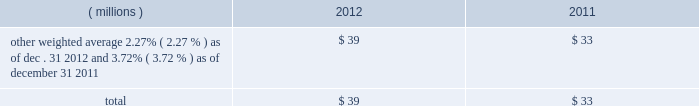2012 ppg annual report and form 10-k 45 costs related to these notes , which totaled $ 17 million , will be amortized to interest expense over the respective terms of the notes .
In august 2010 , ppg entered into a three-year credit agreement with several banks and financial institutions ( the "2010 credit agreement" ) which was subsequently terminated in july 2012 .
The 2010 credit agreement provided for a $ 1.2 billion unsecured revolving credit facility .
In connection with entering into the 2010 credit agreement , the company terminated its 20ac650 million and its $ 1 billion revolving credit facilities that were each set to expire in 2011 .
There were no outstanding amounts due under either revolving facility at the times of their termination .
The 2010 credit agreement was set to terminate on august 5 , 2013 .
Ppg 2019s non-u.s .
Operations have uncommitted lines of credit totaling $ 705 million of which $ 34 million was used as of december 31 , 2012 .
These uncommitted lines of credit are subject to cancellation at any time and are generally not subject to any commitment fees .
Short-term debt outstanding as of december 31 , 2012 and 2011 , was as follows: .
Ppg is in compliance with the restrictive covenants under its various credit agreements , loan agreements and indentures .
The company 2019s revolving credit agreements include a financial ratio covenant .
The covenant requires that the amount of total indebtedness not exceed 60% ( 60 % ) of the company 2019s total capitalization excluding the portion of accumulated other comprehensive income ( loss ) related to pensions and other postretirement benefit adjustments .
As of december 31 , 2012 , total indebtedness was 42% ( 42 % ) of the company 2019s total capitalization excluding the portion of accumulated other comprehensive income ( loss ) related to pensions and other postretirement benefit adjustments .
Additionally , substantially all of the company 2019s debt agreements contain customary cross- default provisions .
Those provisions generally provide that a default on a debt service payment of $ 10 million or more for longer than the grace period provided ( usually 10 days ) under one agreement may result in an event of default under other agreements .
None of the company 2019s primary debt obligations are secured or guaranteed by the company 2019s affiliates .
Interest payments in 2012 , 2011 and 2010 totaled $ 219 million , $ 212 million and $ 189 million , respectively .
In october 2009 , the company entered into an agreement with a counterparty to repurchase up to 1.2 million shares of the company 2019s stock of which 1.1 million shares were purchased in the open market ( 465006 of these shares were purchased as of december 31 , 2009 at a weighted average price of $ 56.66 per share ) .
The counterparty held the shares until september of 2010 when the company paid $ 65 million and took possession of these shares .
Rental expense for operating leases was $ 233 million , $ 249 million and $ 233 million in 2012 , 2011 and 2010 , respectively .
The primary leased assets include paint stores , transportation equipment , warehouses and other distribution facilities , and office space , including the company 2019s corporate headquarters located in pittsburgh , pa .
Minimum lease commitments for operating leases that have initial or remaining lease terms in excess of one year as of december 31 , 2012 , are ( in millions ) $ 171 in 2013 , $ 135 in 2014 , $ 107 in 2015 , $ 83 in 2016 , $ 64 in 2017 and $ 135 thereafter .
The company had outstanding letters of credit and surety bonds of $ 119 million as of december 31 , 2012 .
The letters of credit secure the company 2019s performance to third parties under certain self-insurance programs and other commitments made in the ordinary course of business .
As of december 31 , 2012 and 2011 , guarantees outstanding were $ 96 million and $ 90 million , respectively .
The guarantees relate primarily to debt of certain entities in which ppg has an ownership interest and selected customers of certain of the company 2019s businesses .
A portion of such debt is secured by the assets of the related entities .
The carrying values of these guarantees were $ 11 million and $ 13 million as of december 31 , 2012 and 2011 , respectively , and the fair values were $ 11 million and $ 21 million , as of december 31 , 2012 and 2011 , respectively .
The fair value of each guarantee was estimated by comparing the net present value of two hypothetical cash flow streams , one based on ppg 2019s incremental borrowing rate and the other based on the borrower 2019s incremental borrowing rate , as of the effective date of the guarantee .
Both streams were discounted at a risk free rate of return .
The company does not believe any loss related to these letters of credit , surety bonds or guarantees is likely .
Fair value measurement the accounting guidance on fair value measurements establishes a hierarchy with three levels of inputs used to determine fair value .
Level 1 inputs are quoted prices ( unadjusted ) in active markets for identical assets and liabilities , are considered to be the most reliable evidence of fair value , and should be used whenever available .
Level 2 inputs are observable prices that are not quoted on active exchanges .
Level 3 inputs are unobservable inputs employed for measuring the fair value of assets or liabilities .
Table of contents notes to the consolidated financial statements .
What is the total outstanding letters of credit , surety bonds , and guarantees? 
Computations: ((119 + 96) * 1000000)
Answer: 215000000.0. 